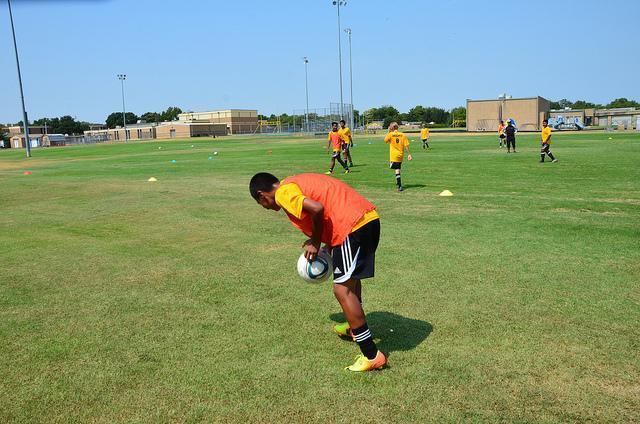How many red color car are there in the image ?
Give a very brief answer. 0. 